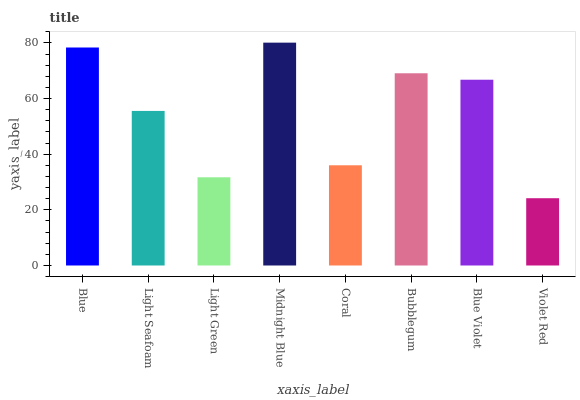Is Violet Red the minimum?
Answer yes or no. Yes. Is Midnight Blue the maximum?
Answer yes or no. Yes. Is Light Seafoam the minimum?
Answer yes or no. No. Is Light Seafoam the maximum?
Answer yes or no. No. Is Blue greater than Light Seafoam?
Answer yes or no. Yes. Is Light Seafoam less than Blue?
Answer yes or no. Yes. Is Light Seafoam greater than Blue?
Answer yes or no. No. Is Blue less than Light Seafoam?
Answer yes or no. No. Is Blue Violet the high median?
Answer yes or no. Yes. Is Light Seafoam the low median?
Answer yes or no. Yes. Is Bubblegum the high median?
Answer yes or no. No. Is Light Green the low median?
Answer yes or no. No. 